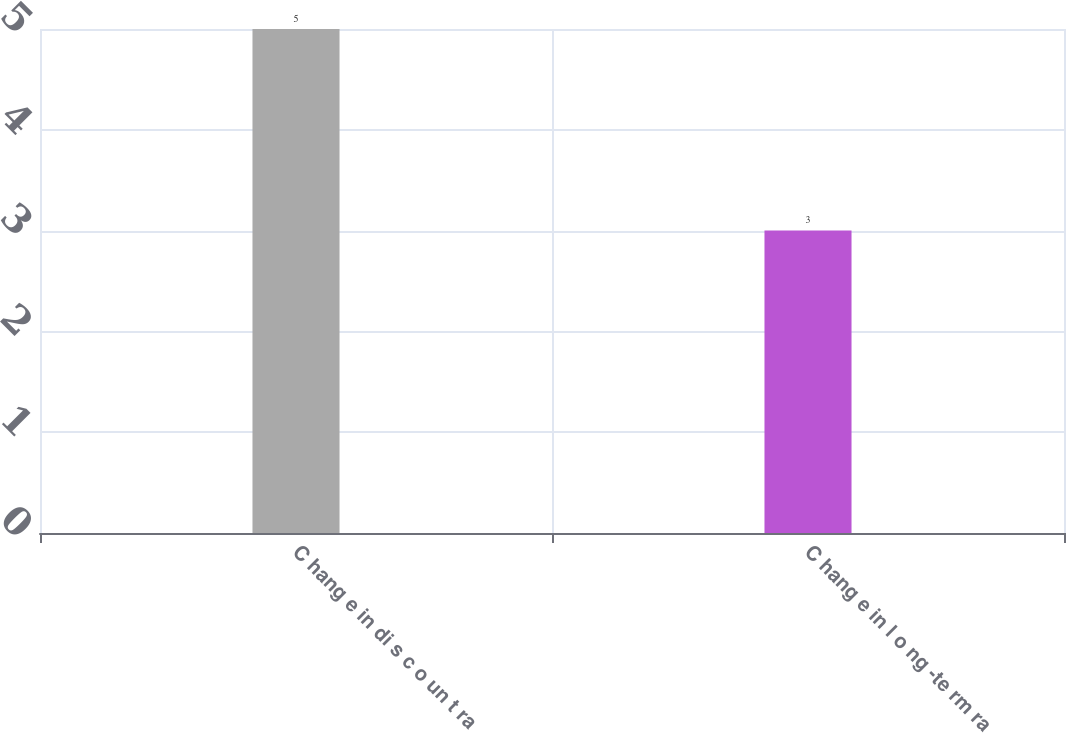<chart> <loc_0><loc_0><loc_500><loc_500><bar_chart><fcel>C hang e in di s c o un t ra<fcel>C hang e in l o ng -te rm ra<nl><fcel>5<fcel>3<nl></chart> 